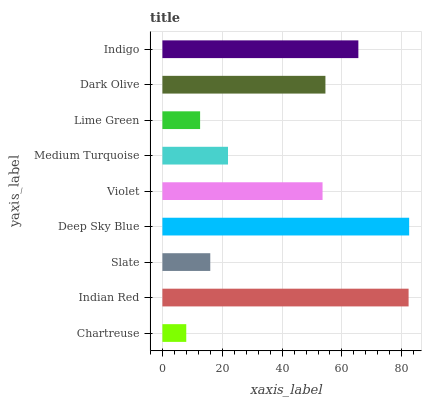Is Chartreuse the minimum?
Answer yes or no. Yes. Is Deep Sky Blue the maximum?
Answer yes or no. Yes. Is Indian Red the minimum?
Answer yes or no. No. Is Indian Red the maximum?
Answer yes or no. No. Is Indian Red greater than Chartreuse?
Answer yes or no. Yes. Is Chartreuse less than Indian Red?
Answer yes or no. Yes. Is Chartreuse greater than Indian Red?
Answer yes or no. No. Is Indian Red less than Chartreuse?
Answer yes or no. No. Is Violet the high median?
Answer yes or no. Yes. Is Violet the low median?
Answer yes or no. Yes. Is Dark Olive the high median?
Answer yes or no. No. Is Indian Red the low median?
Answer yes or no. No. 